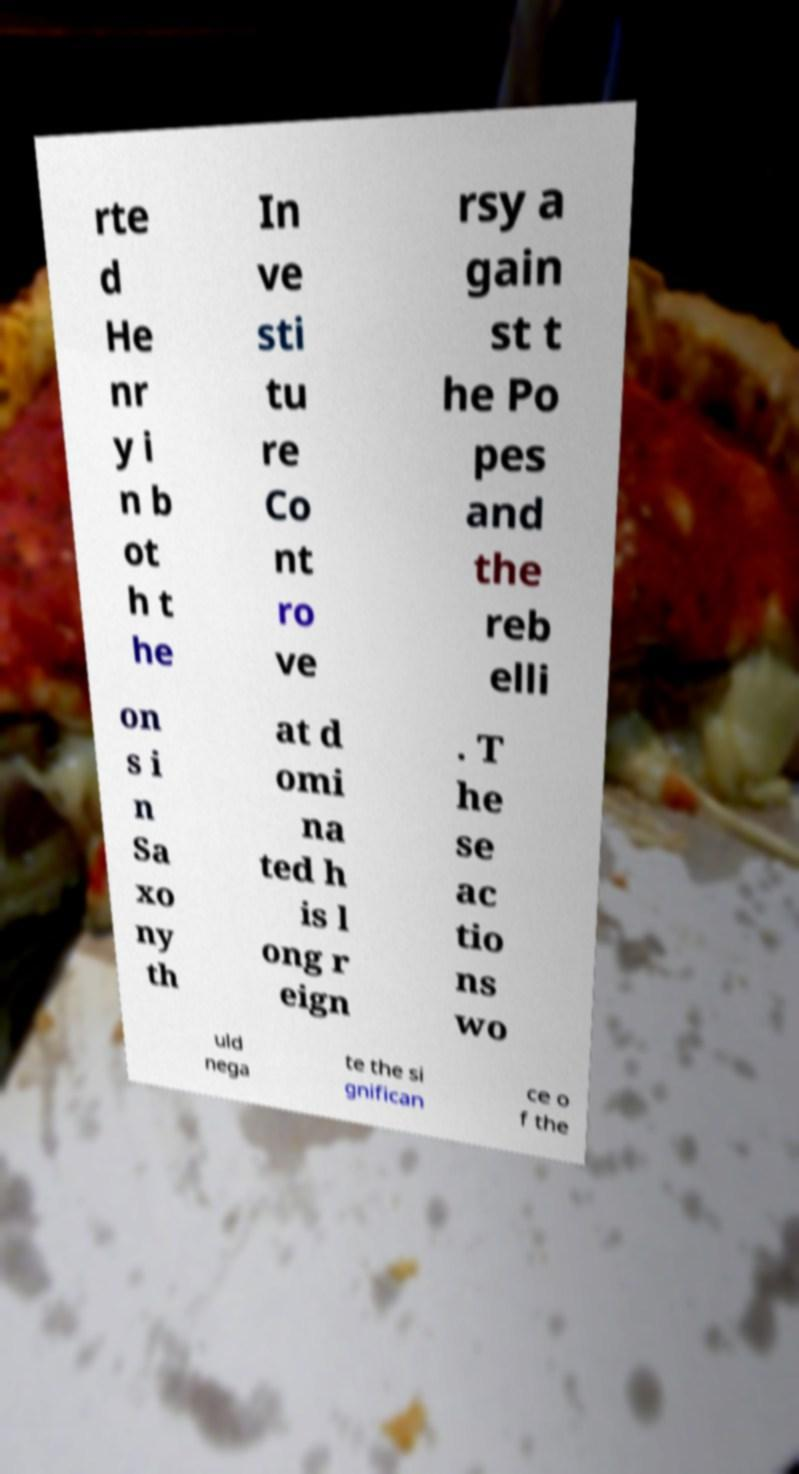What messages or text are displayed in this image? I need them in a readable, typed format. rte d He nr y i n b ot h t he In ve sti tu re Co nt ro ve rsy a gain st t he Po pes and the reb elli on s i n Sa xo ny th at d omi na ted h is l ong r eign . T he se ac tio ns wo uld nega te the si gnifican ce o f the 